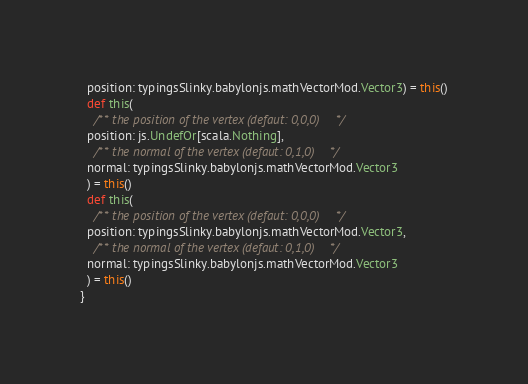Convert code to text. <code><loc_0><loc_0><loc_500><loc_500><_Scala_>  position: typingsSlinky.babylonjs.mathVectorMod.Vector3) = this()
  def this(
    /** the position of the vertex (defaut: 0,0,0) */
  position: js.UndefOr[scala.Nothing],
    /** the normal of the vertex (defaut: 0,1,0) */
  normal: typingsSlinky.babylonjs.mathVectorMod.Vector3
  ) = this()
  def this(
    /** the position of the vertex (defaut: 0,0,0) */
  position: typingsSlinky.babylonjs.mathVectorMod.Vector3,
    /** the normal of the vertex (defaut: 0,1,0) */
  normal: typingsSlinky.babylonjs.mathVectorMod.Vector3
  ) = this()
}
</code> 